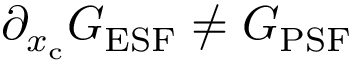Convert formula to latex. <formula><loc_0><loc_0><loc_500><loc_500>\partial _ { x _ { c } } G _ { E S F } \neq G _ { P S F }</formula> 